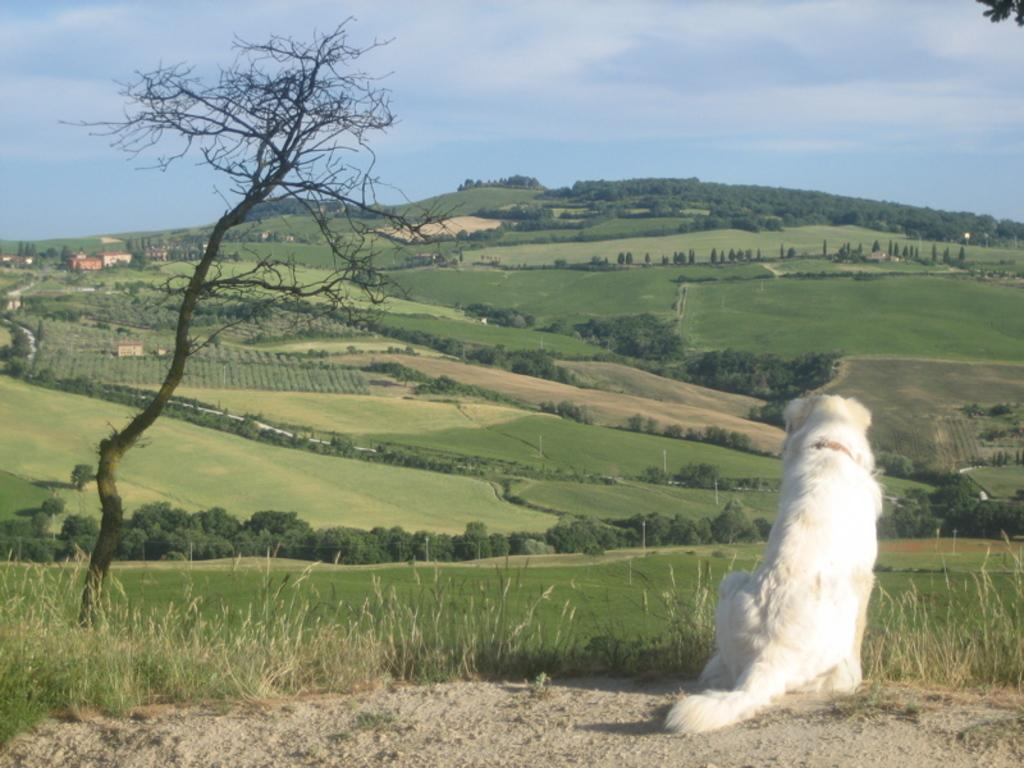What type of vegetation can be seen in the image? There is grass and trees in the image. What animal is present in the image? There is a white-colored dog in the image. What part of the natural environment is visible in the image? The sky is visible in the image. Can you see a zebra wearing a ring in the image? No, there is no zebra or ring present in the image. Is there a school visible in the background of the image? No, there is no school present in the image. 